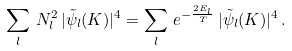Convert formula to latex. <formula><loc_0><loc_0><loc_500><loc_500>\sum _ { l } \, N _ { l } ^ { 2 } \, | \tilde { \psi } _ { l } ( { K } ) | ^ { 4 } = \sum _ { l } \, e ^ { - \frac { 2 E _ { l } } { T } } \, | \tilde { \psi } _ { l } ( { K } ) | ^ { 4 } \, .</formula> 